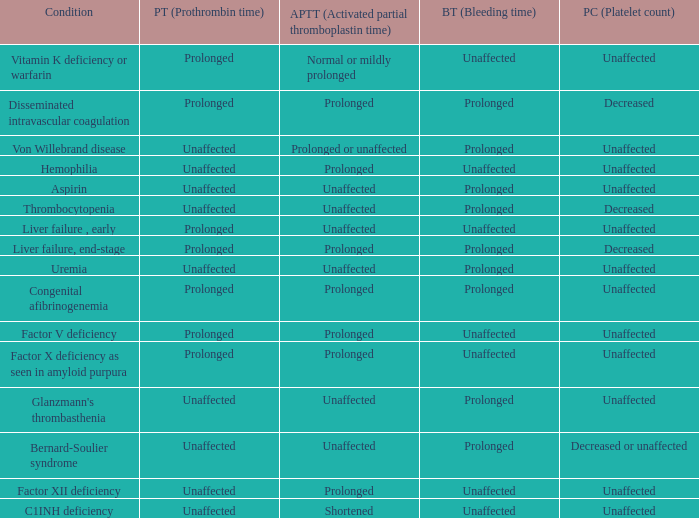Which Platelet count has a Condition of bernard-soulier syndrome? Decreased or unaffected. 